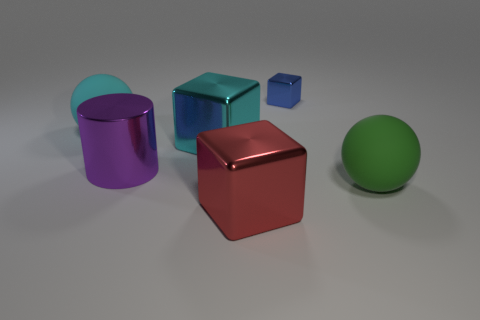There is a large object that is in front of the green object; what color is it?
Make the answer very short. Red. Is the blue thing the same size as the green sphere?
Keep it short and to the point. No. The purple cylinder has what size?
Give a very brief answer. Large. Are there more big gray matte cubes than purple cylinders?
Give a very brief answer. No. What is the color of the big metal block that is to the left of the large object in front of the big rubber ball that is in front of the large purple metal cylinder?
Your answer should be compact. Cyan. Is the shape of the cyan thing in front of the cyan matte ball the same as  the large green matte thing?
Give a very brief answer. No. There is another metal block that is the same size as the cyan cube; what is its color?
Ensure brevity in your answer.  Red. How many big green matte objects are there?
Give a very brief answer. 1. Is the material of the large sphere right of the large red metallic thing the same as the small blue object?
Offer a very short reply. No. The object that is both on the right side of the red object and in front of the blue metallic cube is made of what material?
Provide a succinct answer. Rubber. 